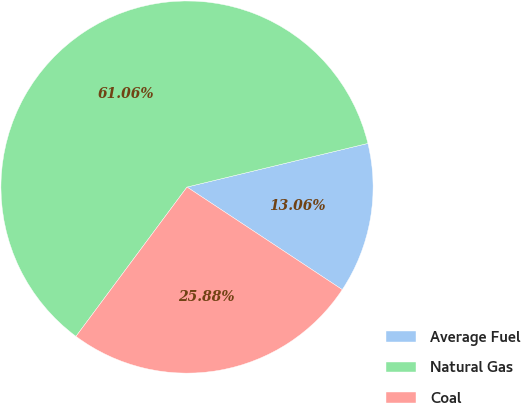Convert chart to OTSL. <chart><loc_0><loc_0><loc_500><loc_500><pie_chart><fcel>Average Fuel<fcel>Natural Gas<fcel>Coal<nl><fcel>13.06%<fcel>61.05%<fcel>25.88%<nl></chart> 